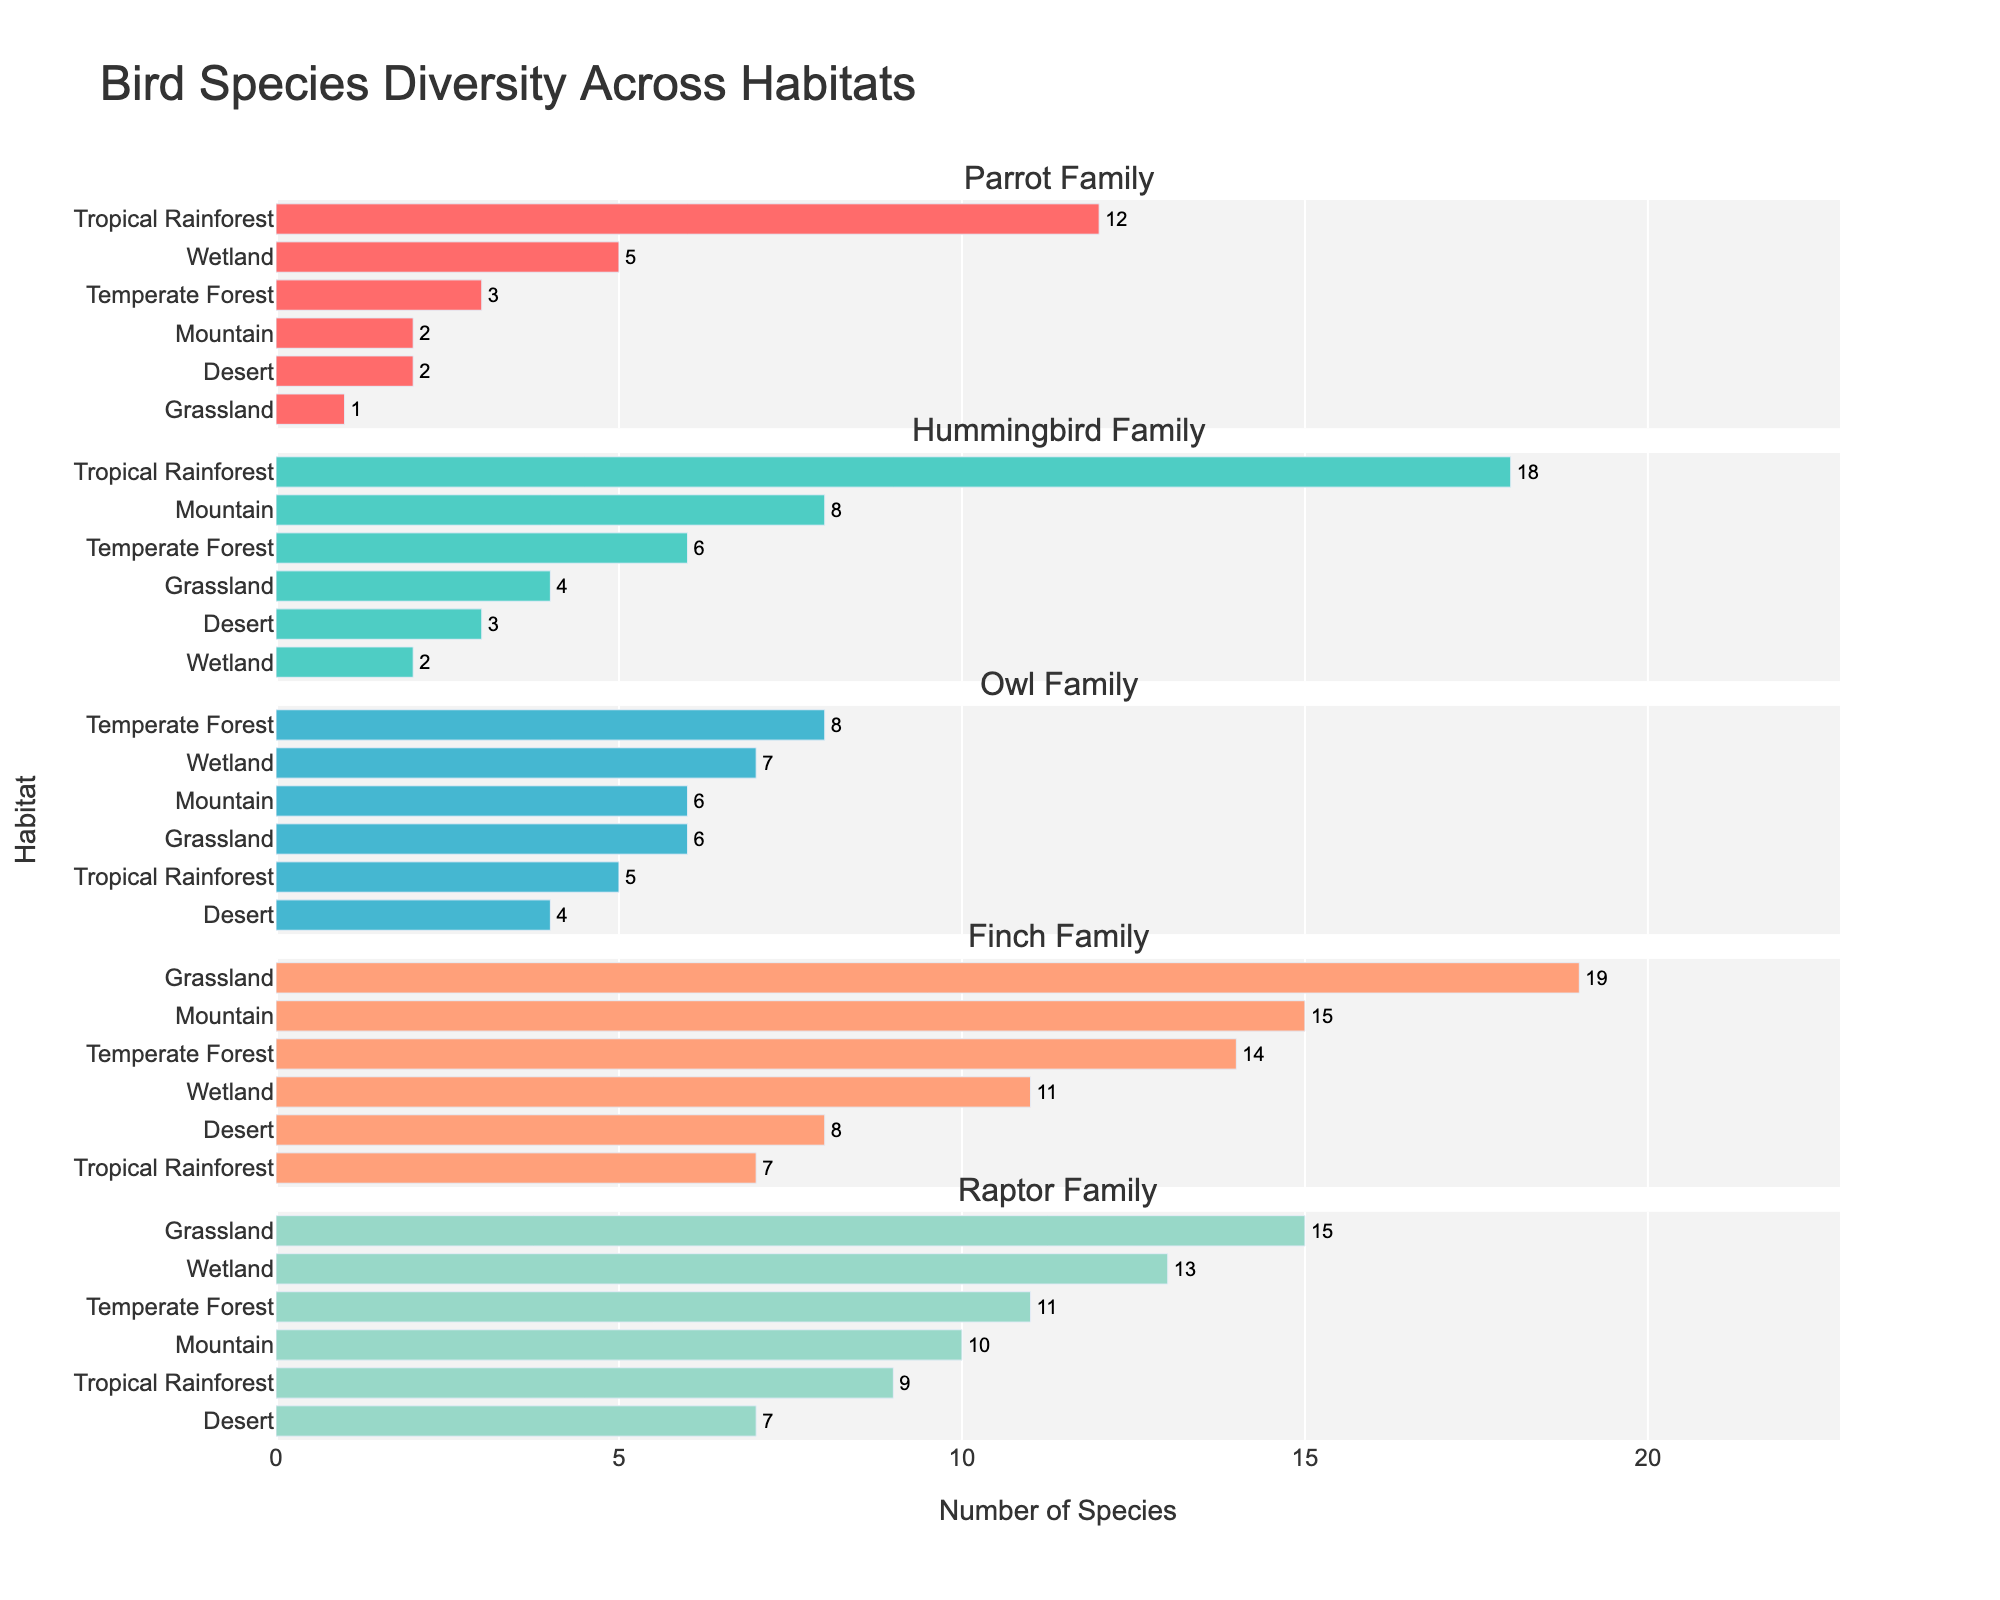Which habitat has the highest number of Hummingbird species? Look at the subplot for the Hummingbird Family and observe the bar lengths. The Tropical Rainforest has the longest bar.
Answer: Tropical Rainforest What is the total number of species in the Parrot Family across all habitats? Sum the values for the Parrot Family in each habitat: 12 (Tropical Rainforest) + 3 (Temperate Forest) + 1 (Grassland) + 2 (Desert) + 5 (Wetland) + 2 (Mountain) = 25.
Answer: 25 Which habitat shows the highest species diversity overall? Identify the habitat with the most even distribution and higher counts across all families. Grassland has high, consistent numbers across multiple families.
Answer: Grassland How many more Finch species are there in Mountain habitats compared to Desert habitats? Subtract the number of Finch species in Desert (8) from the number in Mountain (15): 15 - 8 = 7.
Answer: 7 Which family is most diverse in the Wetland habitat? In the subplot for Wetland, observe which family has the longest bar. The longest bar is for the Raptor Family.
Answer: Raptor Family Compare the number of Owl species in the Temperate Forest to that in the Grassland. Which one is greater? Compare the values for Owl species: 8 (Temperate Forest) and 6 (Grassland). 8 (Temperate Forest) is greater than 6.
Answer: Temperate Forest What is the combined number of species in the Raptor Family across Temperate Forest and Mountain habitats? Add the values for Temperate Forest (11) and Mountain (10): 11 + 10 = 21.
Answer: 21 Which habitat has the lowest number of species across all families? Look for the habitat with the shortest total bar lengths across subplots. Desert has the lowest total number of species across all families.
Answer: Desert Identify the family with the highest species count overall. Sum the values for each family: Parrot Family (25), Hummingbird Family (41), Owl Family (36), Finch Family (74), and Raptor Family (65). Finch Family has the highest count.
Answer: Finch Family How many families have more than 10 species in the Temperate Forest habitat? Count the number of families with values greater than 10 in Temperate Forest: Finch (14), Raptor (11). There are 2 families.
Answer: 2 